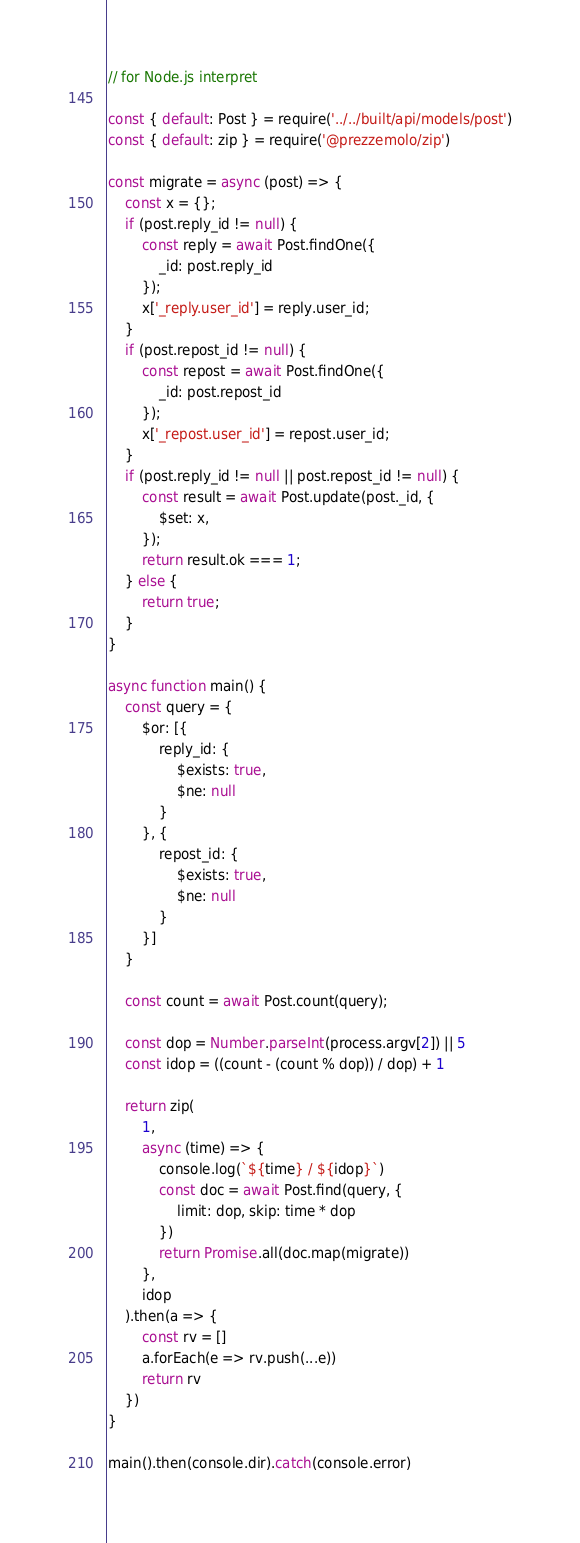Convert code to text. <code><loc_0><loc_0><loc_500><loc_500><_JavaScript_>// for Node.js interpret

const { default: Post } = require('../../built/api/models/post')
const { default: zip } = require('@prezzemolo/zip')

const migrate = async (post) => {
	const x = {};
	if (post.reply_id != null) {
		const reply = await Post.findOne({
			_id: post.reply_id
		});
		x['_reply.user_id'] = reply.user_id;
	}
	if (post.repost_id != null) {
		const repost = await Post.findOne({
			_id: post.repost_id
		});
		x['_repost.user_id'] = repost.user_id;
	}
	if (post.reply_id != null || post.repost_id != null) {
		const result = await Post.update(post._id, {
			$set: x,
		});
		return result.ok === 1;
	} else {
		return true;
	}
}

async function main() {
	const query = {
		$or: [{
			reply_id: {
				$exists: true,
				$ne: null
			}
		}, {
			repost_id: {
				$exists: true,
				$ne: null
			}
		}]
	}

	const count = await Post.count(query);

	const dop = Number.parseInt(process.argv[2]) || 5
	const idop = ((count - (count % dop)) / dop) + 1

	return zip(
		1,
		async (time) => {
			console.log(`${time} / ${idop}`)
			const doc = await Post.find(query, {
				limit: dop, skip: time * dop
			})
			return Promise.all(doc.map(migrate))
		},
		idop
	).then(a => {
		const rv = []
		a.forEach(e => rv.push(...e))
		return rv
	})
}

main().then(console.dir).catch(console.error)
</code> 